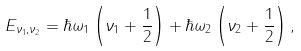<formula> <loc_0><loc_0><loc_500><loc_500>E _ { \nu _ { 1 } , \nu _ { 2 } } = \hbar { \omega } _ { 1 } \left ( \nu _ { 1 } + \frac { 1 } { 2 } \right ) + \hbar { \omega } _ { 2 } \left ( \nu _ { 2 } + \frac { 1 } { 2 } \right ) ,</formula> 